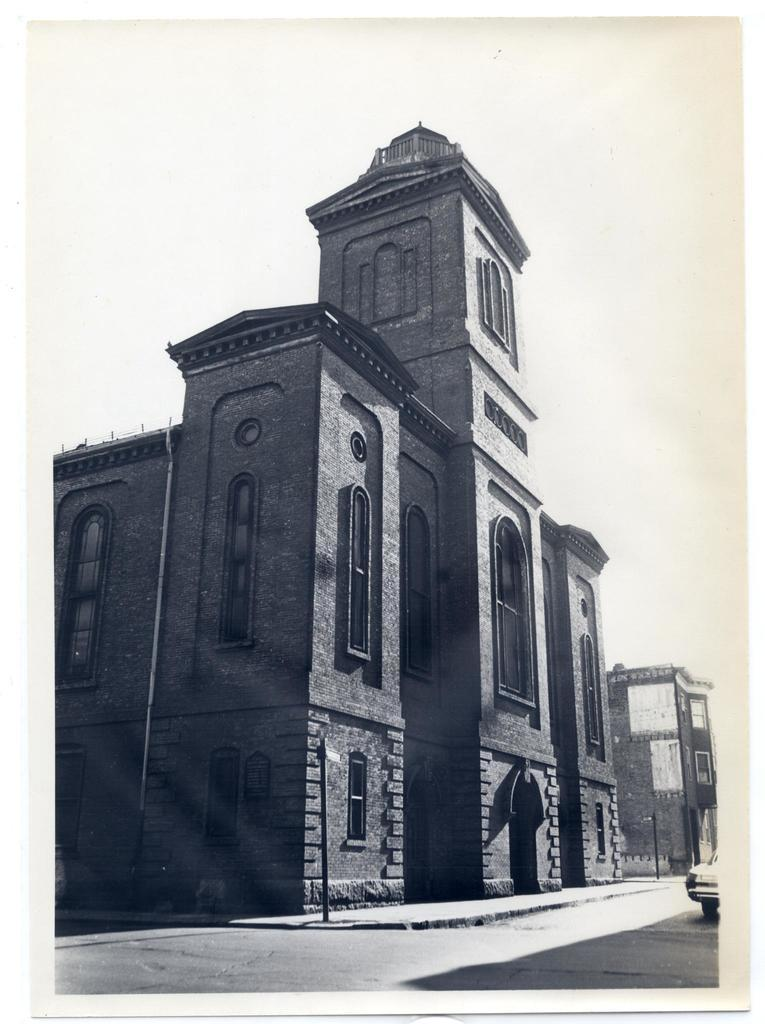What type of structure is visible in the image? There is a building in the image. What is located in front of the building? There is a road in front of the building. Is there any transportation visible on the road? Yes, there is a vehicle on the road. What can be seen at the top of the image? The sky is visible at the top of the image. How many chairs are placed around the building in the image? There are no chairs visible in the image; it only features a building, a road, a vehicle, and the sky. 